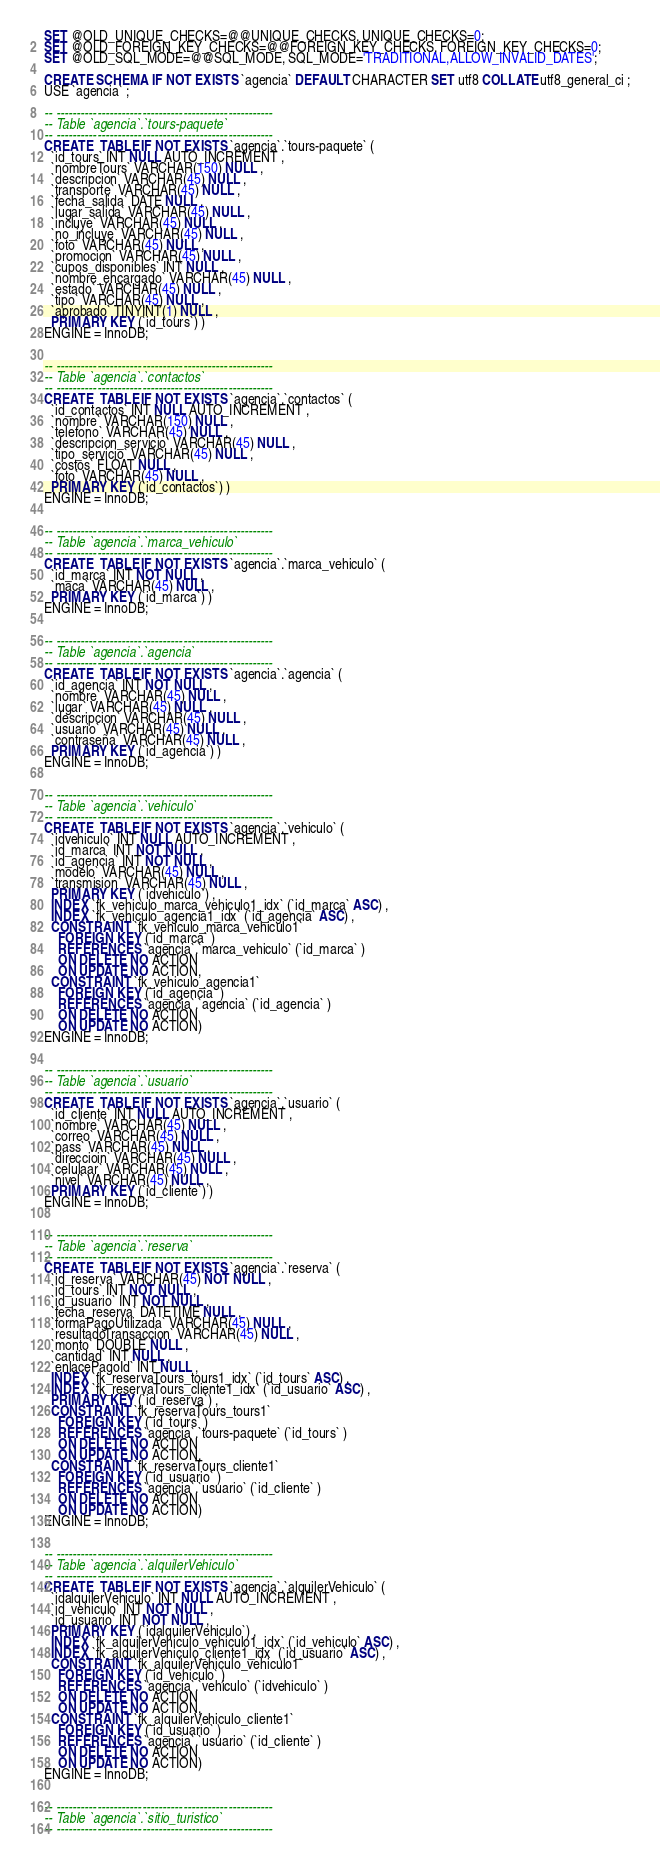Convert code to text. <code><loc_0><loc_0><loc_500><loc_500><_SQL_>SET @OLD_UNIQUE_CHECKS=@@UNIQUE_CHECKS, UNIQUE_CHECKS=0;
SET @OLD_FOREIGN_KEY_CHECKS=@@FOREIGN_KEY_CHECKS, FOREIGN_KEY_CHECKS=0;
SET @OLD_SQL_MODE=@@SQL_MODE, SQL_MODE='TRADITIONAL,ALLOW_INVALID_DATES';

CREATE SCHEMA IF NOT EXISTS `agencia` DEFAULT CHARACTER SET utf8 COLLATE utf8_general_ci ;
USE `agencia` ;

-- -----------------------------------------------------
-- Table `agencia`.`tours-paquete`
-- -----------------------------------------------------
CREATE  TABLE IF NOT EXISTS `agencia`.`tours-paquete` (
  `id_tours` INT NULL AUTO_INCREMENT ,
  `nombreTours` VARCHAR(150) NULL ,
  `descripcion` VARCHAR(45) NULL ,
  `transporte` VARCHAR(45) NULL ,
  `fecha_salida` DATE NULL ,
  `lugar_salida` VARCHAR(45) NULL ,
  `incluye` VARCHAR(45) NULL ,
  `no_incluye` VARCHAR(45) NULL ,
  `foto` VARCHAR(45) NULL ,
  `promocion` VARCHAR(45) NULL ,
  `cupos_disponibles` INT NULL ,
  `nombre_encargado` VARCHAR(45) NULL ,
  `estado` VARCHAR(45) NULL ,
  `tipo` VARCHAR(45) NULL ,
  `aprobado` TINYINT(1) NULL ,
  PRIMARY KEY (`id_tours`) )
ENGINE = InnoDB;


-- -----------------------------------------------------
-- Table `agencia`.`contactos`
-- -----------------------------------------------------
CREATE  TABLE IF NOT EXISTS `agencia`.`contactos` (
  `id_contactos` INT NULL AUTO_INCREMENT ,
  `nombre` VARCHAR(150) NULL ,
  `telefono` VARCHAR(45) NULL ,
  `descripcion_servicio` VARCHAR(45) NULL ,
  `tipo_servicio` VARCHAR(45) NULL ,
  `costos` FLOAT NULL ,
  `foto` VARCHAR(45) NULL ,
  PRIMARY KEY (`id_contactos`) )
ENGINE = InnoDB;


-- -----------------------------------------------------
-- Table `agencia`.`marca_vehiculo`
-- -----------------------------------------------------
CREATE  TABLE IF NOT EXISTS `agencia`.`marca_vehiculo` (
  `id_marca` INT NOT NULL ,
  `maca` VARCHAR(45) NULL ,
  PRIMARY KEY (`id_marca`) )
ENGINE = InnoDB;


-- -----------------------------------------------------
-- Table `agencia`.`agencia`
-- -----------------------------------------------------
CREATE  TABLE IF NOT EXISTS `agencia`.`agencia` (
  `id_agencia` INT NOT NULL ,
  `nombre` VARCHAR(45) NULL ,
  `lugar` VARCHAR(45) NULL ,
  `descripcion` VARCHAR(45) NULL ,
  `usuario` VARCHAR(45) NULL ,
  `contraseña` VARCHAR(45) NULL ,
  PRIMARY KEY (`id_agencia`) )
ENGINE = InnoDB;


-- -----------------------------------------------------
-- Table `agencia`.`vehiculo`
-- -----------------------------------------------------
CREATE  TABLE IF NOT EXISTS `agencia`.`vehiculo` (
  `idvehiculo` INT NULL AUTO_INCREMENT ,
  `id_marca` INT NOT NULL ,
  `id_agencia` INT NOT NULL ,
  `modelo` VARCHAR(45) NULL ,
  `transmision` VARCHAR(45) NULL ,
  PRIMARY KEY (`idvehiculo`) ,
  INDEX `fk_vehiculo_marca_vehiculo1_idx` (`id_marca` ASC) ,
  INDEX `fk_vehiculo_agencia1_idx` (`id_agencia` ASC) ,
  CONSTRAINT `fk_vehiculo_marca_vehiculo1`
    FOREIGN KEY (`id_marca` )
    REFERENCES `agencia`.`marca_vehiculo` (`id_marca` )
    ON DELETE NO ACTION
    ON UPDATE NO ACTION,
  CONSTRAINT `fk_vehiculo_agencia1`
    FOREIGN KEY (`id_agencia` )
    REFERENCES `agencia`.`agencia` (`id_agencia` )
    ON DELETE NO ACTION
    ON UPDATE NO ACTION)
ENGINE = InnoDB;


-- -----------------------------------------------------
-- Table `agencia`.`usuario`
-- -----------------------------------------------------
CREATE  TABLE IF NOT EXISTS `agencia`.`usuario` (
  `id_cliente` INT NULL AUTO_INCREMENT ,
  `nombre` VARCHAR(45) NULL ,
  `correo` VARCHAR(45) NULL ,
  `pass` VARCHAR(45) NULL ,
  `direccioin` VARCHAR(45) NULL ,
  `celulaar` VARCHAR(45) NULL ,
  `nivel` VARCHAR(45) NULL ,
  PRIMARY KEY (`id_cliente`) )
ENGINE = InnoDB;


-- -----------------------------------------------------
-- Table `agencia`.`reserva`
-- -----------------------------------------------------
CREATE  TABLE IF NOT EXISTS `agencia`.`reserva` (
  `id_reserva` VARCHAR(45) NOT NULL ,
  `id_tours` INT NOT NULL ,
  `id_usuario` INT NOT NULL ,
  `fecha_reserva` DATETIME NULL ,
  `formaPagoUtilizada` VARCHAR(45) NULL ,
  `resultadoTransaccion` VARCHAR(45) NULL ,
  `monto` DOUBLE NULL ,
  `cantidad` INT NULL ,
  `enlacePagoId` INT NULL ,
  INDEX `fk_reservaTours_tours1_idx` (`id_tours` ASC) ,
  INDEX `fk_reservaTours_cliente1_idx` (`id_usuario` ASC) ,
  PRIMARY KEY (`id_reserva`) ,
  CONSTRAINT `fk_reservaTours_tours1`
    FOREIGN KEY (`id_tours` )
    REFERENCES `agencia`.`tours-paquete` (`id_tours` )
    ON DELETE NO ACTION
    ON UPDATE NO ACTION,
  CONSTRAINT `fk_reservaTours_cliente1`
    FOREIGN KEY (`id_usuario` )
    REFERENCES `agencia`.`usuario` (`id_cliente` )
    ON DELETE NO ACTION
    ON UPDATE NO ACTION)
ENGINE = InnoDB;


-- -----------------------------------------------------
-- Table `agencia`.`alquilerVehiculo`
-- -----------------------------------------------------
CREATE  TABLE IF NOT EXISTS `agencia`.`alquilerVehiculo` (
  `idalquilerVehiculo` INT NULL AUTO_INCREMENT ,
  `id_vehiculo` INT NOT NULL ,
  `id_usuario` INT NOT NULL ,
  PRIMARY KEY (`idalquilerVehiculo`) ,
  INDEX `fk_alquilerVehiculo_vehiculo1_idx` (`id_vehiculo` ASC) ,
  INDEX `fk_alquilerVehiculo_cliente1_idx` (`id_usuario` ASC) ,
  CONSTRAINT `fk_alquilerVehiculo_vehiculo1`
    FOREIGN KEY (`id_vehiculo` )
    REFERENCES `agencia`.`vehiculo` (`idvehiculo` )
    ON DELETE NO ACTION
    ON UPDATE NO ACTION,
  CONSTRAINT `fk_alquilerVehiculo_cliente1`
    FOREIGN KEY (`id_usuario` )
    REFERENCES `agencia`.`usuario` (`id_cliente` )
    ON DELETE NO ACTION
    ON UPDATE NO ACTION)
ENGINE = InnoDB;


-- -----------------------------------------------------
-- Table `agencia`.`sitio_turistico`
-- -----------------------------------------------------</code> 